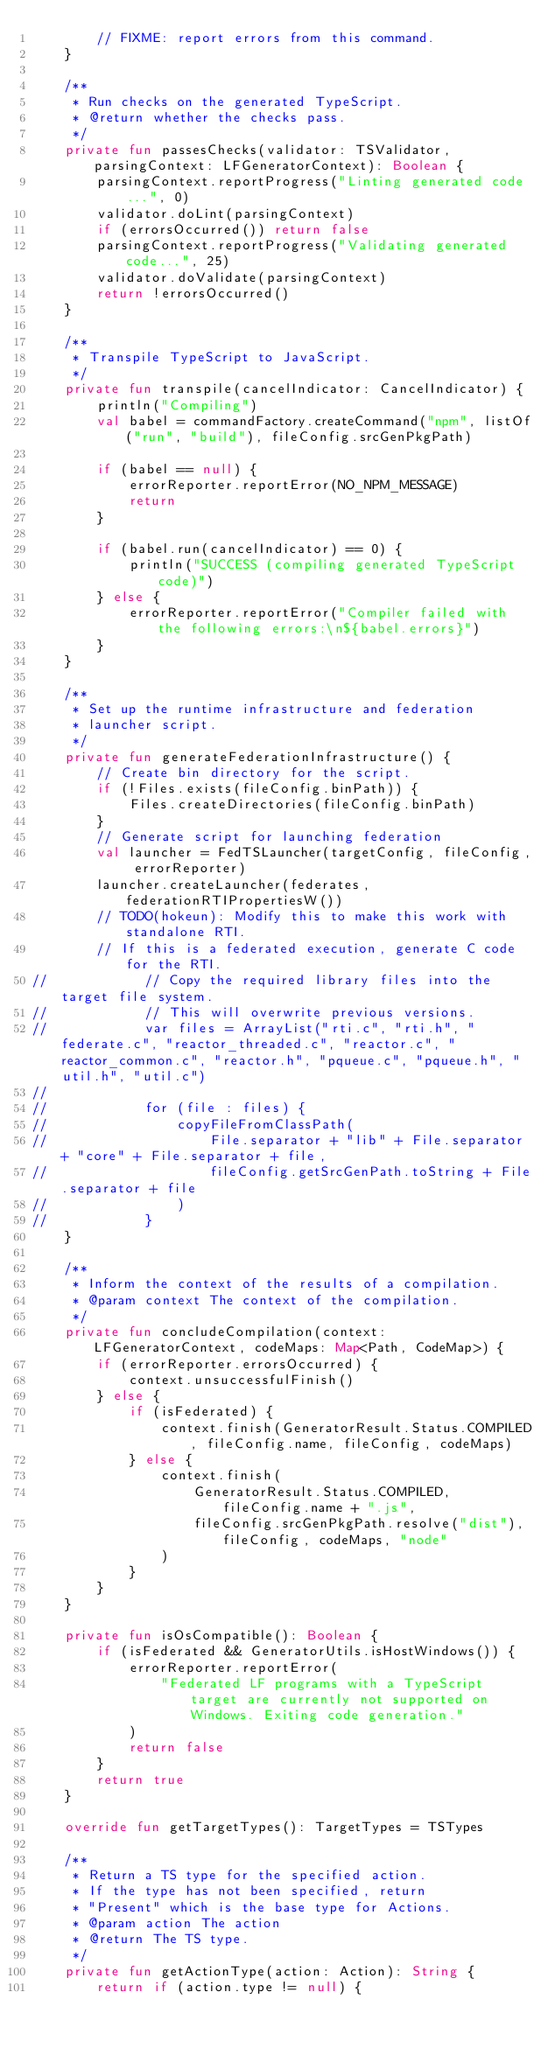<code> <loc_0><loc_0><loc_500><loc_500><_Kotlin_>        // FIXME: report errors from this command.
    }

    /**
     * Run checks on the generated TypeScript.
     * @return whether the checks pass.
     */
    private fun passesChecks(validator: TSValidator, parsingContext: LFGeneratorContext): Boolean {
        parsingContext.reportProgress("Linting generated code...", 0)
        validator.doLint(parsingContext)
        if (errorsOccurred()) return false
        parsingContext.reportProgress("Validating generated code...", 25)
        validator.doValidate(parsingContext)
        return !errorsOccurred()
    }

    /**
     * Transpile TypeScript to JavaScript.
     */
    private fun transpile(cancelIndicator: CancelIndicator) {
        println("Compiling")
        val babel = commandFactory.createCommand("npm", listOf("run", "build"), fileConfig.srcGenPkgPath)

        if (babel == null) {
            errorReporter.reportError(NO_NPM_MESSAGE)
            return
        }

        if (babel.run(cancelIndicator) == 0) {
            println("SUCCESS (compiling generated TypeScript code)")
        } else {
            errorReporter.reportError("Compiler failed with the following errors:\n${babel.errors}")
        }
    }

    /**
     * Set up the runtime infrastructure and federation
     * launcher script.
     */
    private fun generateFederationInfrastructure() {
        // Create bin directory for the script.
        if (!Files.exists(fileConfig.binPath)) {
            Files.createDirectories(fileConfig.binPath)
        }
        // Generate script for launching federation
        val launcher = FedTSLauncher(targetConfig, fileConfig, errorReporter)
        launcher.createLauncher(federates, federationRTIPropertiesW())
        // TODO(hokeun): Modify this to make this work with standalone RTI.
        // If this is a federated execution, generate C code for the RTI.
//            // Copy the required library files into the target file system.
//            // This will overwrite previous versions.
//            var files = ArrayList("rti.c", "rti.h", "federate.c", "reactor_threaded.c", "reactor.c", "reactor_common.c", "reactor.h", "pqueue.c", "pqueue.h", "util.h", "util.c")
//
//            for (file : files) {
//                copyFileFromClassPath(
//                    File.separator + "lib" + File.separator + "core" + File.separator + file,
//                    fileConfig.getSrcGenPath.toString + File.separator + file
//                )
//            }
    }

    /**
     * Inform the context of the results of a compilation.
     * @param context The context of the compilation.
     */
    private fun concludeCompilation(context: LFGeneratorContext, codeMaps: Map<Path, CodeMap>) {
        if (errorReporter.errorsOccurred) {
            context.unsuccessfulFinish()
        } else {
            if (isFederated) {
                context.finish(GeneratorResult.Status.COMPILED, fileConfig.name, fileConfig, codeMaps)
            } else {
                context.finish(
                    GeneratorResult.Status.COMPILED, fileConfig.name + ".js",
                    fileConfig.srcGenPkgPath.resolve("dist"), fileConfig, codeMaps, "node"
                )
            }
        }
    }

    private fun isOsCompatible(): Boolean {
        if (isFederated && GeneratorUtils.isHostWindows()) {
            errorReporter.reportError(
                "Federated LF programs with a TypeScript target are currently not supported on Windows. Exiting code generation."
            )
            return false
        }
        return true
    }

    override fun getTargetTypes(): TargetTypes = TSTypes

    /**
     * Return a TS type for the specified action.
     * If the type has not been specified, return
     * "Present" which is the base type for Actions.
     * @param action The action
     * @return The TS type.
     */
    private fun getActionType(action: Action): String {
        return if (action.type != null) {</code> 